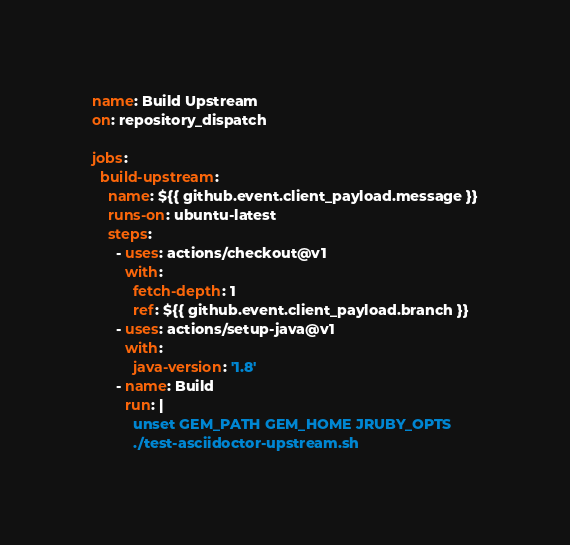Convert code to text. <code><loc_0><loc_0><loc_500><loc_500><_YAML_>name: Build Upstream
on: repository_dispatch

jobs:
  build-upstream:
    name: ${{ github.event.client_payload.message }}
    runs-on: ubuntu-latest
    steps:
      - uses: actions/checkout@v1
        with:
          fetch-depth: 1
          ref: ${{ github.event.client_payload.branch }}
      - uses: actions/setup-java@v1
        with:
          java-version: '1.8'
      - name: Build
        run: |
          unset GEM_PATH GEM_HOME JRUBY_OPTS
          ./test-asciidoctor-upstream.sh
</code> 